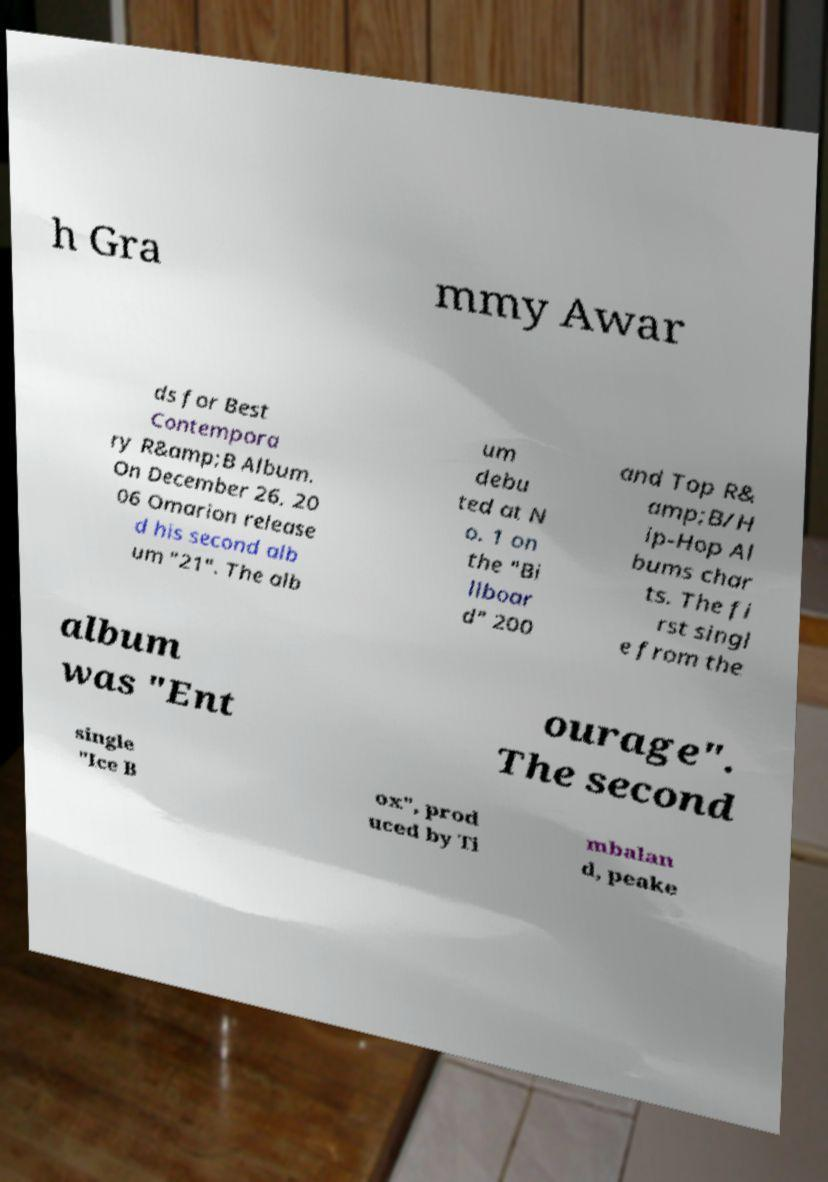Please read and relay the text visible in this image. What does it say? h Gra mmy Awar ds for Best Contempora ry R&amp;B Album. On December 26, 20 06 Omarion release d his second alb um "21". The alb um debu ted at N o. 1 on the "Bi llboar d" 200 and Top R& amp;B/H ip-Hop Al bums char ts. The fi rst singl e from the album was "Ent ourage". The second single "Ice B ox", prod uced by Ti mbalan d, peake 